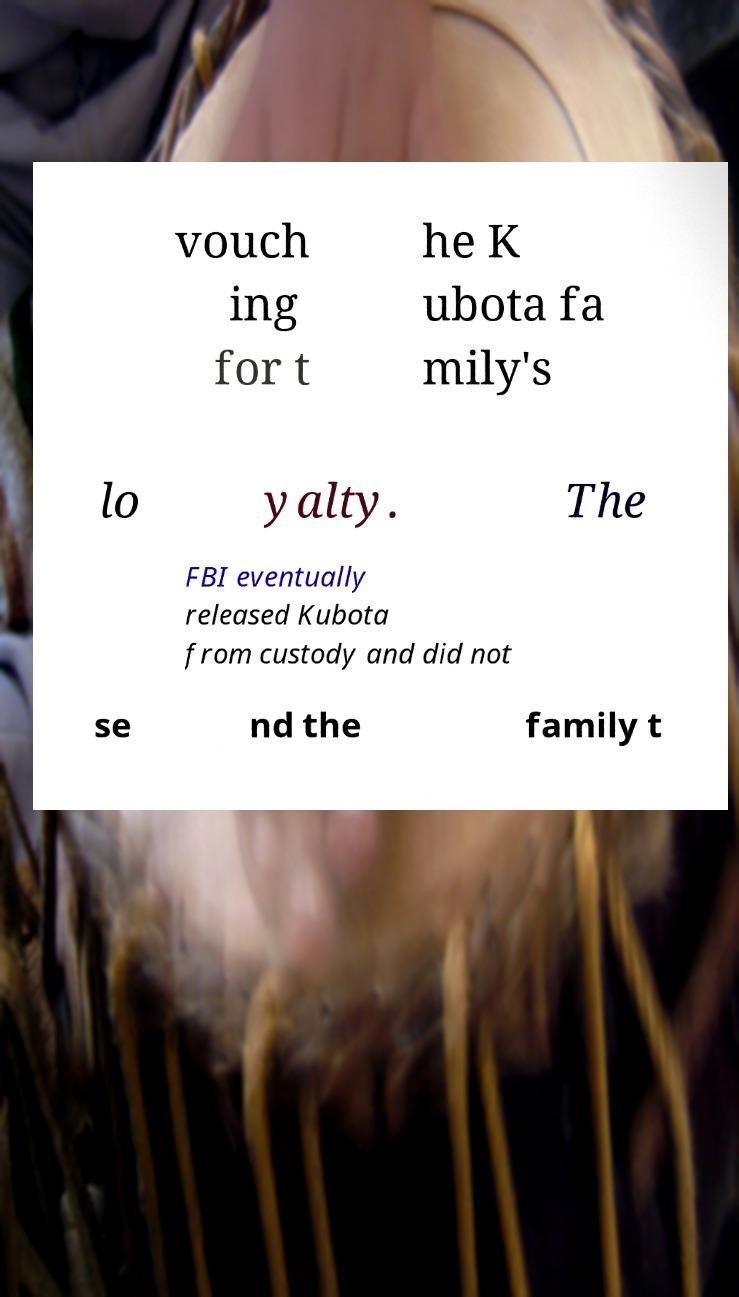There's text embedded in this image that I need extracted. Can you transcribe it verbatim? vouch ing for t he K ubota fa mily's lo yalty. The FBI eventually released Kubota from custody and did not se nd the family t 